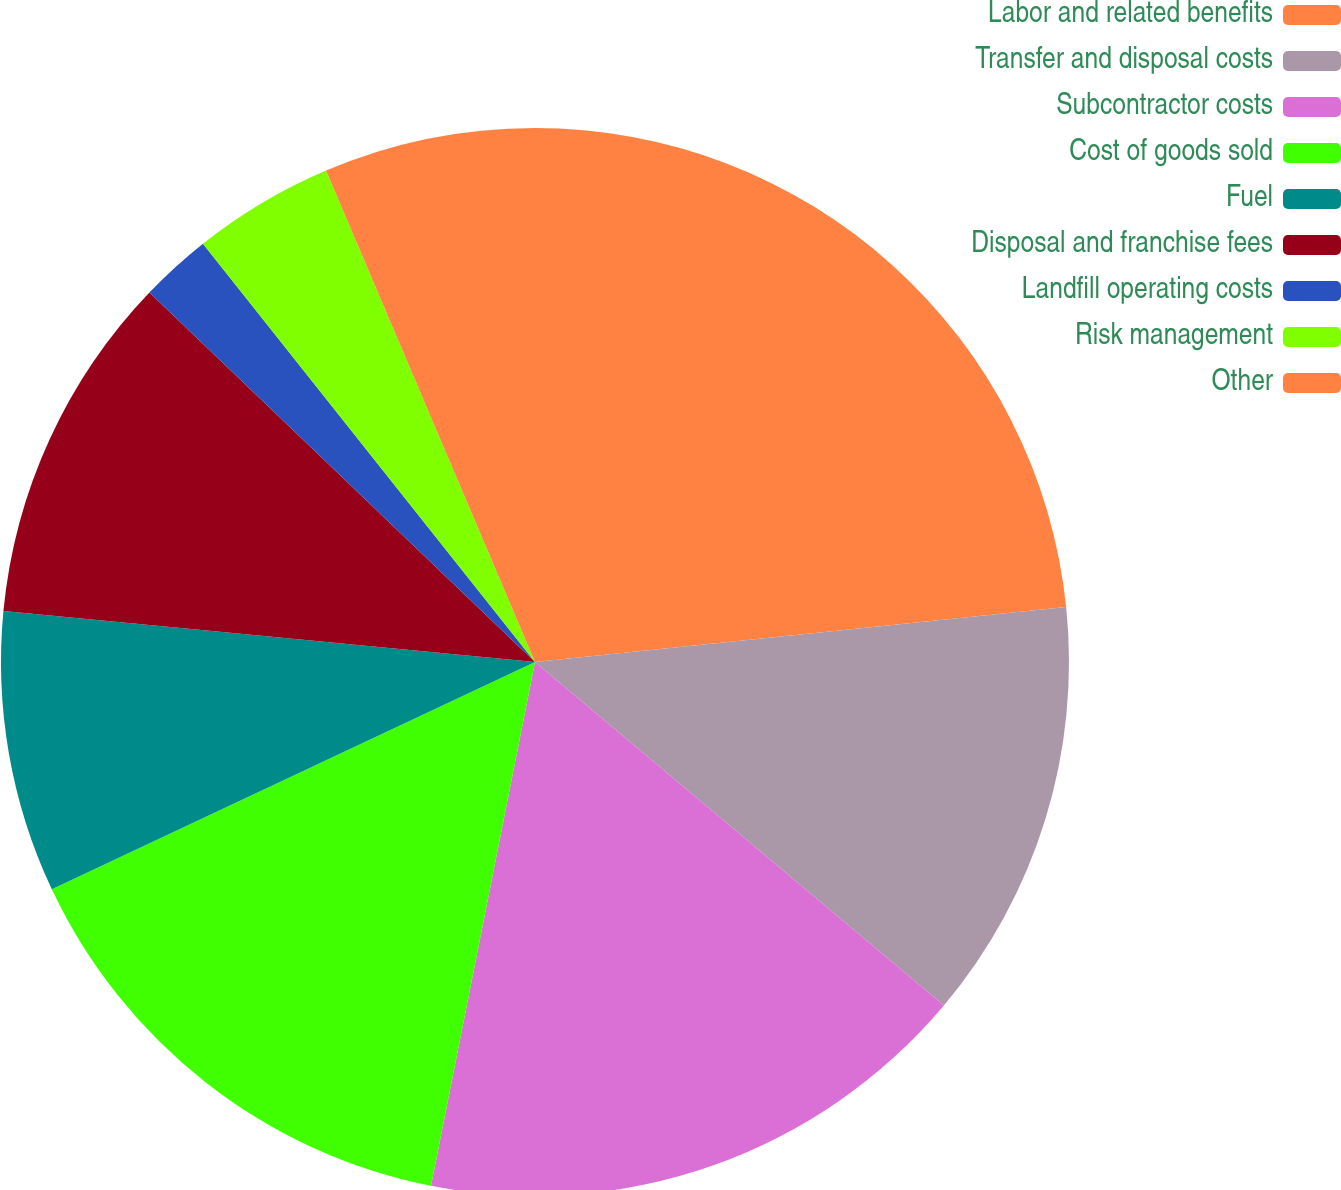Convert chart to OTSL. <chart><loc_0><loc_0><loc_500><loc_500><pie_chart><fcel>Labor and related benefits<fcel>Transfer and disposal costs<fcel>Subcontractor costs<fcel>Cost of goods sold<fcel>Fuel<fcel>Disposal and franchise fees<fcel>Landfill operating costs<fcel>Risk management<fcel>Other<nl><fcel>23.36%<fcel>12.76%<fcel>17.0%<fcel>14.88%<fcel>8.52%<fcel>10.64%<fcel>2.16%<fcel>4.28%<fcel>6.4%<nl></chart> 